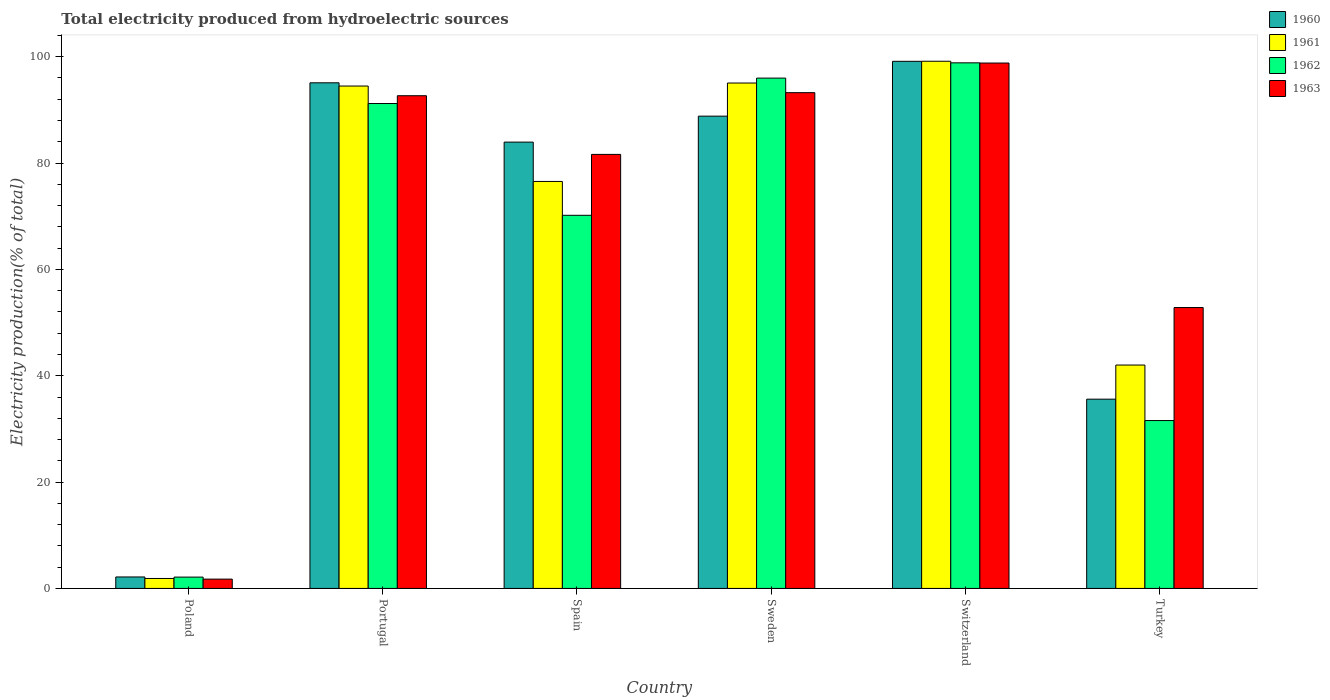How many different coloured bars are there?
Offer a very short reply. 4. How many bars are there on the 5th tick from the left?
Provide a succinct answer. 4. What is the total electricity produced in 1963 in Portugal?
Your answer should be compact. 92.66. Across all countries, what is the maximum total electricity produced in 1960?
Offer a very short reply. 99.13. Across all countries, what is the minimum total electricity produced in 1963?
Ensure brevity in your answer.  1.75. In which country was the total electricity produced in 1962 maximum?
Ensure brevity in your answer.  Switzerland. What is the total total electricity produced in 1960 in the graph?
Your answer should be very brief. 404.73. What is the difference between the total electricity produced in 1960 in Sweden and that in Turkey?
Provide a short and direct response. 53.22. What is the difference between the total electricity produced in 1963 in Sweden and the total electricity produced in 1960 in Switzerland?
Your answer should be very brief. -5.89. What is the average total electricity produced in 1961 per country?
Provide a short and direct response. 68.18. What is the difference between the total electricity produced of/in 1962 and total electricity produced of/in 1960 in Spain?
Give a very brief answer. -13.76. What is the ratio of the total electricity produced in 1963 in Portugal to that in Turkey?
Your answer should be compact. 1.75. Is the total electricity produced in 1963 in Spain less than that in Turkey?
Keep it short and to the point. No. What is the difference between the highest and the second highest total electricity produced in 1961?
Your answer should be very brief. 4.67. What is the difference between the highest and the lowest total electricity produced in 1961?
Offer a very short reply. 97.27. In how many countries, is the total electricity produced in 1963 greater than the average total electricity produced in 1963 taken over all countries?
Keep it short and to the point. 4. Is the sum of the total electricity produced in 1961 in Spain and Turkey greater than the maximum total electricity produced in 1962 across all countries?
Offer a very short reply. Yes. Is it the case that in every country, the sum of the total electricity produced in 1960 and total electricity produced in 1962 is greater than the sum of total electricity produced in 1963 and total electricity produced in 1961?
Make the answer very short. No. What does the 3rd bar from the right in Sweden represents?
Your answer should be compact. 1961. How many bars are there?
Your answer should be very brief. 24. How many countries are there in the graph?
Provide a succinct answer. 6. Are the values on the major ticks of Y-axis written in scientific E-notation?
Provide a succinct answer. No. Does the graph contain any zero values?
Give a very brief answer. No. Where does the legend appear in the graph?
Provide a short and direct response. Top right. How many legend labels are there?
Your answer should be compact. 4. How are the legend labels stacked?
Ensure brevity in your answer.  Vertical. What is the title of the graph?
Make the answer very short. Total electricity produced from hydroelectric sources. What is the label or title of the X-axis?
Your answer should be compact. Country. What is the Electricity production(% of total) in 1960 in Poland?
Give a very brief answer. 2.16. What is the Electricity production(% of total) of 1961 in Poland?
Your answer should be compact. 1.87. What is the Electricity production(% of total) of 1962 in Poland?
Your response must be concise. 2.13. What is the Electricity production(% of total) of 1963 in Poland?
Give a very brief answer. 1.75. What is the Electricity production(% of total) in 1960 in Portugal?
Offer a very short reply. 95.09. What is the Electricity production(% of total) of 1961 in Portugal?
Ensure brevity in your answer.  94.48. What is the Electricity production(% of total) of 1962 in Portugal?
Offer a very short reply. 91.19. What is the Electricity production(% of total) in 1963 in Portugal?
Provide a short and direct response. 92.66. What is the Electricity production(% of total) in 1960 in Spain?
Your answer should be compact. 83.94. What is the Electricity production(% of total) in 1961 in Spain?
Offer a very short reply. 76.54. What is the Electricity production(% of total) in 1962 in Spain?
Make the answer very short. 70.17. What is the Electricity production(% of total) of 1963 in Spain?
Your answer should be compact. 81.63. What is the Electricity production(% of total) of 1960 in Sweden?
Offer a very short reply. 88.82. What is the Electricity production(% of total) in 1961 in Sweden?
Your answer should be very brief. 95.05. What is the Electricity production(% of total) of 1962 in Sweden?
Keep it short and to the point. 95.98. What is the Electricity production(% of total) in 1963 in Sweden?
Give a very brief answer. 93.24. What is the Electricity production(% of total) in 1960 in Switzerland?
Your answer should be very brief. 99.13. What is the Electricity production(% of total) of 1961 in Switzerland?
Your answer should be compact. 99.15. What is the Electricity production(% of total) in 1962 in Switzerland?
Provide a succinct answer. 98.85. What is the Electricity production(% of total) in 1963 in Switzerland?
Provide a succinct answer. 98.81. What is the Electricity production(% of total) of 1960 in Turkey?
Provide a short and direct response. 35.6. What is the Electricity production(% of total) in 1961 in Turkey?
Your answer should be very brief. 42.01. What is the Electricity production(% of total) of 1962 in Turkey?
Give a very brief answer. 31.57. What is the Electricity production(% of total) of 1963 in Turkey?
Keep it short and to the point. 52.82. Across all countries, what is the maximum Electricity production(% of total) in 1960?
Provide a succinct answer. 99.13. Across all countries, what is the maximum Electricity production(% of total) of 1961?
Give a very brief answer. 99.15. Across all countries, what is the maximum Electricity production(% of total) in 1962?
Keep it short and to the point. 98.85. Across all countries, what is the maximum Electricity production(% of total) of 1963?
Offer a terse response. 98.81. Across all countries, what is the minimum Electricity production(% of total) of 1960?
Provide a succinct answer. 2.16. Across all countries, what is the minimum Electricity production(% of total) of 1961?
Provide a short and direct response. 1.87. Across all countries, what is the minimum Electricity production(% of total) in 1962?
Offer a very short reply. 2.13. Across all countries, what is the minimum Electricity production(% of total) of 1963?
Provide a succinct answer. 1.75. What is the total Electricity production(% of total) of 1960 in the graph?
Your answer should be compact. 404.73. What is the total Electricity production(% of total) of 1961 in the graph?
Offer a terse response. 409.1. What is the total Electricity production(% of total) of 1962 in the graph?
Give a very brief answer. 389.89. What is the total Electricity production(% of total) of 1963 in the graph?
Provide a short and direct response. 420.91. What is the difference between the Electricity production(% of total) in 1960 in Poland and that in Portugal?
Offer a terse response. -92.93. What is the difference between the Electricity production(% of total) in 1961 in Poland and that in Portugal?
Provide a succinct answer. -92.61. What is the difference between the Electricity production(% of total) in 1962 in Poland and that in Portugal?
Give a very brief answer. -89.06. What is the difference between the Electricity production(% of total) of 1963 in Poland and that in Portugal?
Your answer should be very brief. -90.91. What is the difference between the Electricity production(% of total) in 1960 in Poland and that in Spain?
Offer a very short reply. -81.78. What is the difference between the Electricity production(% of total) in 1961 in Poland and that in Spain?
Provide a short and direct response. -74.67. What is the difference between the Electricity production(% of total) in 1962 in Poland and that in Spain?
Your answer should be compact. -68.04. What is the difference between the Electricity production(% of total) of 1963 in Poland and that in Spain?
Provide a succinct answer. -79.88. What is the difference between the Electricity production(% of total) of 1960 in Poland and that in Sweden?
Keep it short and to the point. -86.66. What is the difference between the Electricity production(% of total) in 1961 in Poland and that in Sweden?
Offer a terse response. -93.17. What is the difference between the Electricity production(% of total) in 1962 in Poland and that in Sweden?
Keep it short and to the point. -93.84. What is the difference between the Electricity production(% of total) in 1963 in Poland and that in Sweden?
Ensure brevity in your answer.  -91.48. What is the difference between the Electricity production(% of total) in 1960 in Poland and that in Switzerland?
Your response must be concise. -96.97. What is the difference between the Electricity production(% of total) in 1961 in Poland and that in Switzerland?
Give a very brief answer. -97.27. What is the difference between the Electricity production(% of total) in 1962 in Poland and that in Switzerland?
Your response must be concise. -96.71. What is the difference between the Electricity production(% of total) of 1963 in Poland and that in Switzerland?
Your answer should be compact. -97.06. What is the difference between the Electricity production(% of total) of 1960 in Poland and that in Turkey?
Provide a succinct answer. -33.44. What is the difference between the Electricity production(% of total) in 1961 in Poland and that in Turkey?
Keep it short and to the point. -40.14. What is the difference between the Electricity production(% of total) in 1962 in Poland and that in Turkey?
Make the answer very short. -29.44. What is the difference between the Electricity production(% of total) of 1963 in Poland and that in Turkey?
Keep it short and to the point. -51.07. What is the difference between the Electricity production(% of total) in 1960 in Portugal and that in Spain?
Provide a short and direct response. 11.15. What is the difference between the Electricity production(% of total) of 1961 in Portugal and that in Spain?
Your answer should be compact. 17.94. What is the difference between the Electricity production(% of total) in 1962 in Portugal and that in Spain?
Provide a short and direct response. 21.02. What is the difference between the Electricity production(% of total) in 1963 in Portugal and that in Spain?
Your answer should be very brief. 11.03. What is the difference between the Electricity production(% of total) of 1960 in Portugal and that in Sweden?
Your response must be concise. 6.27. What is the difference between the Electricity production(% of total) in 1961 in Portugal and that in Sweden?
Give a very brief answer. -0.57. What is the difference between the Electricity production(% of total) of 1962 in Portugal and that in Sweden?
Provide a short and direct response. -4.78. What is the difference between the Electricity production(% of total) of 1963 in Portugal and that in Sweden?
Your response must be concise. -0.58. What is the difference between the Electricity production(% of total) in 1960 in Portugal and that in Switzerland?
Offer a very short reply. -4.04. What is the difference between the Electricity production(% of total) in 1961 in Portugal and that in Switzerland?
Provide a short and direct response. -4.67. What is the difference between the Electricity production(% of total) of 1962 in Portugal and that in Switzerland?
Your answer should be very brief. -7.65. What is the difference between the Electricity production(% of total) in 1963 in Portugal and that in Switzerland?
Provide a short and direct response. -6.15. What is the difference between the Electricity production(% of total) of 1960 in Portugal and that in Turkey?
Ensure brevity in your answer.  59.49. What is the difference between the Electricity production(% of total) of 1961 in Portugal and that in Turkey?
Your response must be concise. 52.47. What is the difference between the Electricity production(% of total) of 1962 in Portugal and that in Turkey?
Your answer should be very brief. 59.62. What is the difference between the Electricity production(% of total) in 1963 in Portugal and that in Turkey?
Offer a very short reply. 39.84. What is the difference between the Electricity production(% of total) of 1960 in Spain and that in Sweden?
Your answer should be compact. -4.88. What is the difference between the Electricity production(% of total) in 1961 in Spain and that in Sweden?
Give a very brief answer. -18.51. What is the difference between the Electricity production(% of total) in 1962 in Spain and that in Sweden?
Your answer should be compact. -25.8. What is the difference between the Electricity production(% of total) of 1963 in Spain and that in Sweden?
Your response must be concise. -11.61. What is the difference between the Electricity production(% of total) in 1960 in Spain and that in Switzerland?
Offer a very short reply. -15.19. What is the difference between the Electricity production(% of total) in 1961 in Spain and that in Switzerland?
Your answer should be very brief. -22.61. What is the difference between the Electricity production(% of total) in 1962 in Spain and that in Switzerland?
Your response must be concise. -28.67. What is the difference between the Electricity production(% of total) in 1963 in Spain and that in Switzerland?
Offer a very short reply. -17.18. What is the difference between the Electricity production(% of total) of 1960 in Spain and that in Turkey?
Provide a succinct answer. 48.34. What is the difference between the Electricity production(% of total) of 1961 in Spain and that in Turkey?
Offer a terse response. 34.53. What is the difference between the Electricity production(% of total) in 1962 in Spain and that in Turkey?
Make the answer very short. 38.6. What is the difference between the Electricity production(% of total) in 1963 in Spain and that in Turkey?
Your response must be concise. 28.8. What is the difference between the Electricity production(% of total) in 1960 in Sweden and that in Switzerland?
Your response must be concise. -10.31. What is the difference between the Electricity production(% of total) of 1961 in Sweden and that in Switzerland?
Your answer should be very brief. -4.1. What is the difference between the Electricity production(% of total) of 1962 in Sweden and that in Switzerland?
Offer a very short reply. -2.87. What is the difference between the Electricity production(% of total) of 1963 in Sweden and that in Switzerland?
Give a very brief answer. -5.57. What is the difference between the Electricity production(% of total) of 1960 in Sweden and that in Turkey?
Your answer should be compact. 53.22. What is the difference between the Electricity production(% of total) in 1961 in Sweden and that in Turkey?
Offer a terse response. 53.04. What is the difference between the Electricity production(% of total) of 1962 in Sweden and that in Turkey?
Keep it short and to the point. 64.4. What is the difference between the Electricity production(% of total) of 1963 in Sweden and that in Turkey?
Provide a succinct answer. 40.41. What is the difference between the Electricity production(% of total) in 1960 in Switzerland and that in Turkey?
Provide a short and direct response. 63.54. What is the difference between the Electricity production(% of total) of 1961 in Switzerland and that in Turkey?
Ensure brevity in your answer.  57.13. What is the difference between the Electricity production(% of total) of 1962 in Switzerland and that in Turkey?
Your answer should be very brief. 67.27. What is the difference between the Electricity production(% of total) of 1963 in Switzerland and that in Turkey?
Offer a very short reply. 45.98. What is the difference between the Electricity production(% of total) of 1960 in Poland and the Electricity production(% of total) of 1961 in Portugal?
Your response must be concise. -92.32. What is the difference between the Electricity production(% of total) in 1960 in Poland and the Electricity production(% of total) in 1962 in Portugal?
Your answer should be compact. -89.03. What is the difference between the Electricity production(% of total) in 1960 in Poland and the Electricity production(% of total) in 1963 in Portugal?
Your response must be concise. -90.5. What is the difference between the Electricity production(% of total) of 1961 in Poland and the Electricity production(% of total) of 1962 in Portugal?
Give a very brief answer. -89.32. What is the difference between the Electricity production(% of total) of 1961 in Poland and the Electricity production(% of total) of 1963 in Portugal?
Offer a terse response. -90.79. What is the difference between the Electricity production(% of total) of 1962 in Poland and the Electricity production(% of total) of 1963 in Portugal?
Provide a short and direct response. -90.53. What is the difference between the Electricity production(% of total) in 1960 in Poland and the Electricity production(% of total) in 1961 in Spain?
Your response must be concise. -74.38. What is the difference between the Electricity production(% of total) in 1960 in Poland and the Electricity production(% of total) in 1962 in Spain?
Your response must be concise. -68.01. What is the difference between the Electricity production(% of total) in 1960 in Poland and the Electricity production(% of total) in 1963 in Spain?
Your response must be concise. -79.47. What is the difference between the Electricity production(% of total) in 1961 in Poland and the Electricity production(% of total) in 1962 in Spain?
Make the answer very short. -68.3. What is the difference between the Electricity production(% of total) of 1961 in Poland and the Electricity production(% of total) of 1963 in Spain?
Ensure brevity in your answer.  -79.75. What is the difference between the Electricity production(% of total) of 1962 in Poland and the Electricity production(% of total) of 1963 in Spain?
Offer a very short reply. -79.5. What is the difference between the Electricity production(% of total) in 1960 in Poland and the Electricity production(% of total) in 1961 in Sweden?
Ensure brevity in your answer.  -92.89. What is the difference between the Electricity production(% of total) of 1960 in Poland and the Electricity production(% of total) of 1962 in Sweden?
Make the answer very short. -93.82. What is the difference between the Electricity production(% of total) in 1960 in Poland and the Electricity production(% of total) in 1963 in Sweden?
Your answer should be compact. -91.08. What is the difference between the Electricity production(% of total) in 1961 in Poland and the Electricity production(% of total) in 1962 in Sweden?
Offer a terse response. -94.1. What is the difference between the Electricity production(% of total) of 1961 in Poland and the Electricity production(% of total) of 1963 in Sweden?
Your answer should be compact. -91.36. What is the difference between the Electricity production(% of total) of 1962 in Poland and the Electricity production(% of total) of 1963 in Sweden?
Provide a succinct answer. -91.1. What is the difference between the Electricity production(% of total) in 1960 in Poland and the Electricity production(% of total) in 1961 in Switzerland?
Keep it short and to the point. -96.99. What is the difference between the Electricity production(% of total) of 1960 in Poland and the Electricity production(% of total) of 1962 in Switzerland?
Make the answer very short. -96.69. What is the difference between the Electricity production(% of total) in 1960 in Poland and the Electricity production(% of total) in 1963 in Switzerland?
Your answer should be very brief. -96.65. What is the difference between the Electricity production(% of total) in 1961 in Poland and the Electricity production(% of total) in 1962 in Switzerland?
Offer a terse response. -96.97. What is the difference between the Electricity production(% of total) in 1961 in Poland and the Electricity production(% of total) in 1963 in Switzerland?
Your response must be concise. -96.93. What is the difference between the Electricity production(% of total) of 1962 in Poland and the Electricity production(% of total) of 1963 in Switzerland?
Your response must be concise. -96.67. What is the difference between the Electricity production(% of total) in 1960 in Poland and the Electricity production(% of total) in 1961 in Turkey?
Your response must be concise. -39.85. What is the difference between the Electricity production(% of total) of 1960 in Poland and the Electricity production(% of total) of 1962 in Turkey?
Offer a very short reply. -29.41. What is the difference between the Electricity production(% of total) of 1960 in Poland and the Electricity production(% of total) of 1963 in Turkey?
Offer a very short reply. -50.67. What is the difference between the Electricity production(% of total) of 1961 in Poland and the Electricity production(% of total) of 1962 in Turkey?
Give a very brief answer. -29.7. What is the difference between the Electricity production(% of total) of 1961 in Poland and the Electricity production(% of total) of 1963 in Turkey?
Provide a succinct answer. -50.95. What is the difference between the Electricity production(% of total) of 1962 in Poland and the Electricity production(% of total) of 1963 in Turkey?
Your answer should be compact. -50.69. What is the difference between the Electricity production(% of total) of 1960 in Portugal and the Electricity production(% of total) of 1961 in Spain?
Offer a very short reply. 18.55. What is the difference between the Electricity production(% of total) of 1960 in Portugal and the Electricity production(% of total) of 1962 in Spain?
Your answer should be very brief. 24.92. What is the difference between the Electricity production(% of total) in 1960 in Portugal and the Electricity production(% of total) in 1963 in Spain?
Your answer should be very brief. 13.46. What is the difference between the Electricity production(% of total) in 1961 in Portugal and the Electricity production(% of total) in 1962 in Spain?
Provide a short and direct response. 24.31. What is the difference between the Electricity production(% of total) of 1961 in Portugal and the Electricity production(% of total) of 1963 in Spain?
Offer a very short reply. 12.85. What is the difference between the Electricity production(% of total) of 1962 in Portugal and the Electricity production(% of total) of 1963 in Spain?
Provide a short and direct response. 9.57. What is the difference between the Electricity production(% of total) in 1960 in Portugal and the Electricity production(% of total) in 1961 in Sweden?
Offer a terse response. 0.04. What is the difference between the Electricity production(% of total) of 1960 in Portugal and the Electricity production(% of total) of 1962 in Sweden?
Give a very brief answer. -0.89. What is the difference between the Electricity production(% of total) of 1960 in Portugal and the Electricity production(% of total) of 1963 in Sweden?
Your answer should be compact. 1.85. What is the difference between the Electricity production(% of total) of 1961 in Portugal and the Electricity production(% of total) of 1962 in Sweden?
Your answer should be very brief. -1.49. What is the difference between the Electricity production(% of total) of 1961 in Portugal and the Electricity production(% of total) of 1963 in Sweden?
Offer a terse response. 1.24. What is the difference between the Electricity production(% of total) of 1962 in Portugal and the Electricity production(% of total) of 1963 in Sweden?
Make the answer very short. -2.04. What is the difference between the Electricity production(% of total) in 1960 in Portugal and the Electricity production(% of total) in 1961 in Switzerland?
Provide a succinct answer. -4.06. What is the difference between the Electricity production(% of total) of 1960 in Portugal and the Electricity production(% of total) of 1962 in Switzerland?
Make the answer very short. -3.76. What is the difference between the Electricity production(% of total) in 1960 in Portugal and the Electricity production(% of total) in 1963 in Switzerland?
Give a very brief answer. -3.72. What is the difference between the Electricity production(% of total) of 1961 in Portugal and the Electricity production(% of total) of 1962 in Switzerland?
Your answer should be compact. -4.37. What is the difference between the Electricity production(% of total) in 1961 in Portugal and the Electricity production(% of total) in 1963 in Switzerland?
Keep it short and to the point. -4.33. What is the difference between the Electricity production(% of total) in 1962 in Portugal and the Electricity production(% of total) in 1963 in Switzerland?
Provide a short and direct response. -7.61. What is the difference between the Electricity production(% of total) of 1960 in Portugal and the Electricity production(% of total) of 1961 in Turkey?
Offer a very short reply. 53.08. What is the difference between the Electricity production(% of total) of 1960 in Portugal and the Electricity production(% of total) of 1962 in Turkey?
Ensure brevity in your answer.  63.52. What is the difference between the Electricity production(% of total) of 1960 in Portugal and the Electricity production(% of total) of 1963 in Turkey?
Your answer should be very brief. 42.27. What is the difference between the Electricity production(% of total) of 1961 in Portugal and the Electricity production(% of total) of 1962 in Turkey?
Offer a very short reply. 62.91. What is the difference between the Electricity production(% of total) of 1961 in Portugal and the Electricity production(% of total) of 1963 in Turkey?
Keep it short and to the point. 41.66. What is the difference between the Electricity production(% of total) of 1962 in Portugal and the Electricity production(% of total) of 1963 in Turkey?
Keep it short and to the point. 38.37. What is the difference between the Electricity production(% of total) of 1960 in Spain and the Electricity production(% of total) of 1961 in Sweden?
Offer a terse response. -11.11. What is the difference between the Electricity production(% of total) of 1960 in Spain and the Electricity production(% of total) of 1962 in Sweden?
Offer a very short reply. -12.04. What is the difference between the Electricity production(% of total) in 1960 in Spain and the Electricity production(% of total) in 1963 in Sweden?
Ensure brevity in your answer.  -9.3. What is the difference between the Electricity production(% of total) of 1961 in Spain and the Electricity production(% of total) of 1962 in Sweden?
Give a very brief answer. -19.44. What is the difference between the Electricity production(% of total) of 1961 in Spain and the Electricity production(% of total) of 1963 in Sweden?
Offer a very short reply. -16.7. What is the difference between the Electricity production(% of total) of 1962 in Spain and the Electricity production(% of total) of 1963 in Sweden?
Offer a very short reply. -23.06. What is the difference between the Electricity production(% of total) of 1960 in Spain and the Electricity production(% of total) of 1961 in Switzerland?
Offer a very short reply. -15.21. What is the difference between the Electricity production(% of total) in 1960 in Spain and the Electricity production(% of total) in 1962 in Switzerland?
Give a very brief answer. -14.91. What is the difference between the Electricity production(% of total) of 1960 in Spain and the Electricity production(% of total) of 1963 in Switzerland?
Your answer should be very brief. -14.87. What is the difference between the Electricity production(% of total) in 1961 in Spain and the Electricity production(% of total) in 1962 in Switzerland?
Your answer should be very brief. -22.31. What is the difference between the Electricity production(% of total) in 1961 in Spain and the Electricity production(% of total) in 1963 in Switzerland?
Your answer should be very brief. -22.27. What is the difference between the Electricity production(% of total) of 1962 in Spain and the Electricity production(% of total) of 1963 in Switzerland?
Offer a terse response. -28.63. What is the difference between the Electricity production(% of total) of 1960 in Spain and the Electricity production(% of total) of 1961 in Turkey?
Offer a terse response. 41.92. What is the difference between the Electricity production(% of total) in 1960 in Spain and the Electricity production(% of total) in 1962 in Turkey?
Keep it short and to the point. 52.36. What is the difference between the Electricity production(% of total) in 1960 in Spain and the Electricity production(% of total) in 1963 in Turkey?
Give a very brief answer. 31.11. What is the difference between the Electricity production(% of total) in 1961 in Spain and the Electricity production(% of total) in 1962 in Turkey?
Keep it short and to the point. 44.97. What is the difference between the Electricity production(% of total) in 1961 in Spain and the Electricity production(% of total) in 1963 in Turkey?
Ensure brevity in your answer.  23.72. What is the difference between the Electricity production(% of total) of 1962 in Spain and the Electricity production(% of total) of 1963 in Turkey?
Keep it short and to the point. 17.35. What is the difference between the Electricity production(% of total) of 1960 in Sweden and the Electricity production(% of total) of 1961 in Switzerland?
Make the answer very short. -10.33. What is the difference between the Electricity production(% of total) of 1960 in Sweden and the Electricity production(% of total) of 1962 in Switzerland?
Offer a terse response. -10.03. What is the difference between the Electricity production(% of total) of 1960 in Sweden and the Electricity production(% of total) of 1963 in Switzerland?
Provide a short and direct response. -9.99. What is the difference between the Electricity production(% of total) in 1961 in Sweden and the Electricity production(% of total) in 1962 in Switzerland?
Provide a short and direct response. -3.8. What is the difference between the Electricity production(% of total) of 1961 in Sweden and the Electricity production(% of total) of 1963 in Switzerland?
Keep it short and to the point. -3.76. What is the difference between the Electricity production(% of total) in 1962 in Sweden and the Electricity production(% of total) in 1963 in Switzerland?
Provide a short and direct response. -2.83. What is the difference between the Electricity production(% of total) of 1960 in Sweden and the Electricity production(% of total) of 1961 in Turkey?
Make the answer very short. 46.81. What is the difference between the Electricity production(% of total) of 1960 in Sweden and the Electricity production(% of total) of 1962 in Turkey?
Provide a short and direct response. 57.25. What is the difference between the Electricity production(% of total) of 1960 in Sweden and the Electricity production(% of total) of 1963 in Turkey?
Offer a terse response. 36. What is the difference between the Electricity production(% of total) in 1961 in Sweden and the Electricity production(% of total) in 1962 in Turkey?
Your response must be concise. 63.48. What is the difference between the Electricity production(% of total) in 1961 in Sweden and the Electricity production(% of total) in 1963 in Turkey?
Ensure brevity in your answer.  42.22. What is the difference between the Electricity production(% of total) in 1962 in Sweden and the Electricity production(% of total) in 1963 in Turkey?
Your answer should be very brief. 43.15. What is the difference between the Electricity production(% of total) in 1960 in Switzerland and the Electricity production(% of total) in 1961 in Turkey?
Your response must be concise. 57.12. What is the difference between the Electricity production(% of total) in 1960 in Switzerland and the Electricity production(% of total) in 1962 in Turkey?
Provide a succinct answer. 67.56. What is the difference between the Electricity production(% of total) of 1960 in Switzerland and the Electricity production(% of total) of 1963 in Turkey?
Keep it short and to the point. 46.31. What is the difference between the Electricity production(% of total) of 1961 in Switzerland and the Electricity production(% of total) of 1962 in Turkey?
Your answer should be compact. 67.57. What is the difference between the Electricity production(% of total) in 1961 in Switzerland and the Electricity production(% of total) in 1963 in Turkey?
Keep it short and to the point. 46.32. What is the difference between the Electricity production(% of total) of 1962 in Switzerland and the Electricity production(% of total) of 1963 in Turkey?
Your answer should be compact. 46.02. What is the average Electricity production(% of total) of 1960 per country?
Offer a terse response. 67.45. What is the average Electricity production(% of total) in 1961 per country?
Keep it short and to the point. 68.18. What is the average Electricity production(% of total) of 1962 per country?
Your answer should be compact. 64.98. What is the average Electricity production(% of total) of 1963 per country?
Give a very brief answer. 70.15. What is the difference between the Electricity production(% of total) in 1960 and Electricity production(% of total) in 1961 in Poland?
Make the answer very short. 0.28. What is the difference between the Electricity production(% of total) of 1960 and Electricity production(% of total) of 1962 in Poland?
Offer a terse response. 0.03. What is the difference between the Electricity production(% of total) of 1960 and Electricity production(% of total) of 1963 in Poland?
Ensure brevity in your answer.  0.41. What is the difference between the Electricity production(% of total) of 1961 and Electricity production(% of total) of 1962 in Poland?
Your answer should be compact. -0.26. What is the difference between the Electricity production(% of total) of 1961 and Electricity production(% of total) of 1963 in Poland?
Your response must be concise. 0.12. What is the difference between the Electricity production(% of total) in 1962 and Electricity production(% of total) in 1963 in Poland?
Your response must be concise. 0.38. What is the difference between the Electricity production(% of total) of 1960 and Electricity production(% of total) of 1961 in Portugal?
Provide a short and direct response. 0.61. What is the difference between the Electricity production(% of total) of 1960 and Electricity production(% of total) of 1962 in Portugal?
Your answer should be compact. 3.9. What is the difference between the Electricity production(% of total) in 1960 and Electricity production(% of total) in 1963 in Portugal?
Offer a very short reply. 2.43. What is the difference between the Electricity production(% of total) of 1961 and Electricity production(% of total) of 1962 in Portugal?
Provide a succinct answer. 3.29. What is the difference between the Electricity production(% of total) in 1961 and Electricity production(% of total) in 1963 in Portugal?
Keep it short and to the point. 1.82. What is the difference between the Electricity production(% of total) in 1962 and Electricity production(% of total) in 1963 in Portugal?
Provide a succinct answer. -1.47. What is the difference between the Electricity production(% of total) of 1960 and Electricity production(% of total) of 1961 in Spain?
Offer a very short reply. 7.4. What is the difference between the Electricity production(% of total) in 1960 and Electricity production(% of total) in 1962 in Spain?
Make the answer very short. 13.76. What is the difference between the Electricity production(% of total) of 1960 and Electricity production(% of total) of 1963 in Spain?
Your response must be concise. 2.31. What is the difference between the Electricity production(% of total) of 1961 and Electricity production(% of total) of 1962 in Spain?
Offer a terse response. 6.37. What is the difference between the Electricity production(% of total) of 1961 and Electricity production(% of total) of 1963 in Spain?
Your answer should be compact. -5.09. What is the difference between the Electricity production(% of total) in 1962 and Electricity production(% of total) in 1963 in Spain?
Your answer should be very brief. -11.45. What is the difference between the Electricity production(% of total) in 1960 and Electricity production(% of total) in 1961 in Sweden?
Provide a succinct answer. -6.23. What is the difference between the Electricity production(% of total) in 1960 and Electricity production(% of total) in 1962 in Sweden?
Give a very brief answer. -7.16. What is the difference between the Electricity production(% of total) in 1960 and Electricity production(% of total) in 1963 in Sweden?
Offer a very short reply. -4.42. What is the difference between the Electricity production(% of total) in 1961 and Electricity production(% of total) in 1962 in Sweden?
Offer a very short reply. -0.93. What is the difference between the Electricity production(% of total) in 1961 and Electricity production(% of total) in 1963 in Sweden?
Provide a succinct answer. 1.81. What is the difference between the Electricity production(% of total) in 1962 and Electricity production(% of total) in 1963 in Sweden?
Your answer should be very brief. 2.74. What is the difference between the Electricity production(% of total) in 1960 and Electricity production(% of total) in 1961 in Switzerland?
Offer a terse response. -0.02. What is the difference between the Electricity production(% of total) in 1960 and Electricity production(% of total) in 1962 in Switzerland?
Your answer should be very brief. 0.28. What is the difference between the Electricity production(% of total) in 1960 and Electricity production(% of total) in 1963 in Switzerland?
Offer a very short reply. 0.32. What is the difference between the Electricity production(% of total) of 1961 and Electricity production(% of total) of 1962 in Switzerland?
Your answer should be compact. 0.3. What is the difference between the Electricity production(% of total) of 1961 and Electricity production(% of total) of 1963 in Switzerland?
Your answer should be very brief. 0.34. What is the difference between the Electricity production(% of total) in 1962 and Electricity production(% of total) in 1963 in Switzerland?
Give a very brief answer. 0.04. What is the difference between the Electricity production(% of total) in 1960 and Electricity production(% of total) in 1961 in Turkey?
Provide a short and direct response. -6.42. What is the difference between the Electricity production(% of total) in 1960 and Electricity production(% of total) in 1962 in Turkey?
Provide a short and direct response. 4.02. What is the difference between the Electricity production(% of total) in 1960 and Electricity production(% of total) in 1963 in Turkey?
Ensure brevity in your answer.  -17.23. What is the difference between the Electricity production(% of total) of 1961 and Electricity production(% of total) of 1962 in Turkey?
Give a very brief answer. 10.44. What is the difference between the Electricity production(% of total) in 1961 and Electricity production(% of total) in 1963 in Turkey?
Offer a terse response. -10.81. What is the difference between the Electricity production(% of total) of 1962 and Electricity production(% of total) of 1963 in Turkey?
Provide a short and direct response. -21.25. What is the ratio of the Electricity production(% of total) in 1960 in Poland to that in Portugal?
Give a very brief answer. 0.02. What is the ratio of the Electricity production(% of total) of 1961 in Poland to that in Portugal?
Your answer should be very brief. 0.02. What is the ratio of the Electricity production(% of total) in 1962 in Poland to that in Portugal?
Make the answer very short. 0.02. What is the ratio of the Electricity production(% of total) in 1963 in Poland to that in Portugal?
Keep it short and to the point. 0.02. What is the ratio of the Electricity production(% of total) in 1960 in Poland to that in Spain?
Your response must be concise. 0.03. What is the ratio of the Electricity production(% of total) in 1961 in Poland to that in Spain?
Your response must be concise. 0.02. What is the ratio of the Electricity production(% of total) in 1962 in Poland to that in Spain?
Give a very brief answer. 0.03. What is the ratio of the Electricity production(% of total) in 1963 in Poland to that in Spain?
Provide a succinct answer. 0.02. What is the ratio of the Electricity production(% of total) of 1960 in Poland to that in Sweden?
Your response must be concise. 0.02. What is the ratio of the Electricity production(% of total) in 1961 in Poland to that in Sweden?
Ensure brevity in your answer.  0.02. What is the ratio of the Electricity production(% of total) in 1962 in Poland to that in Sweden?
Make the answer very short. 0.02. What is the ratio of the Electricity production(% of total) in 1963 in Poland to that in Sweden?
Keep it short and to the point. 0.02. What is the ratio of the Electricity production(% of total) of 1960 in Poland to that in Switzerland?
Give a very brief answer. 0.02. What is the ratio of the Electricity production(% of total) in 1961 in Poland to that in Switzerland?
Offer a very short reply. 0.02. What is the ratio of the Electricity production(% of total) in 1962 in Poland to that in Switzerland?
Keep it short and to the point. 0.02. What is the ratio of the Electricity production(% of total) of 1963 in Poland to that in Switzerland?
Offer a terse response. 0.02. What is the ratio of the Electricity production(% of total) of 1960 in Poland to that in Turkey?
Provide a succinct answer. 0.06. What is the ratio of the Electricity production(% of total) of 1961 in Poland to that in Turkey?
Provide a short and direct response. 0.04. What is the ratio of the Electricity production(% of total) in 1962 in Poland to that in Turkey?
Make the answer very short. 0.07. What is the ratio of the Electricity production(% of total) of 1963 in Poland to that in Turkey?
Provide a succinct answer. 0.03. What is the ratio of the Electricity production(% of total) of 1960 in Portugal to that in Spain?
Your response must be concise. 1.13. What is the ratio of the Electricity production(% of total) in 1961 in Portugal to that in Spain?
Provide a succinct answer. 1.23. What is the ratio of the Electricity production(% of total) of 1962 in Portugal to that in Spain?
Keep it short and to the point. 1.3. What is the ratio of the Electricity production(% of total) of 1963 in Portugal to that in Spain?
Your answer should be compact. 1.14. What is the ratio of the Electricity production(% of total) of 1960 in Portugal to that in Sweden?
Provide a short and direct response. 1.07. What is the ratio of the Electricity production(% of total) in 1961 in Portugal to that in Sweden?
Your response must be concise. 0.99. What is the ratio of the Electricity production(% of total) in 1962 in Portugal to that in Sweden?
Offer a very short reply. 0.95. What is the ratio of the Electricity production(% of total) of 1960 in Portugal to that in Switzerland?
Your answer should be compact. 0.96. What is the ratio of the Electricity production(% of total) in 1961 in Portugal to that in Switzerland?
Provide a short and direct response. 0.95. What is the ratio of the Electricity production(% of total) of 1962 in Portugal to that in Switzerland?
Keep it short and to the point. 0.92. What is the ratio of the Electricity production(% of total) of 1963 in Portugal to that in Switzerland?
Provide a succinct answer. 0.94. What is the ratio of the Electricity production(% of total) in 1960 in Portugal to that in Turkey?
Your response must be concise. 2.67. What is the ratio of the Electricity production(% of total) in 1961 in Portugal to that in Turkey?
Your response must be concise. 2.25. What is the ratio of the Electricity production(% of total) in 1962 in Portugal to that in Turkey?
Provide a succinct answer. 2.89. What is the ratio of the Electricity production(% of total) of 1963 in Portugal to that in Turkey?
Provide a succinct answer. 1.75. What is the ratio of the Electricity production(% of total) in 1960 in Spain to that in Sweden?
Your answer should be compact. 0.94. What is the ratio of the Electricity production(% of total) of 1961 in Spain to that in Sweden?
Your answer should be very brief. 0.81. What is the ratio of the Electricity production(% of total) of 1962 in Spain to that in Sweden?
Your answer should be compact. 0.73. What is the ratio of the Electricity production(% of total) of 1963 in Spain to that in Sweden?
Your answer should be very brief. 0.88. What is the ratio of the Electricity production(% of total) in 1960 in Spain to that in Switzerland?
Your response must be concise. 0.85. What is the ratio of the Electricity production(% of total) of 1961 in Spain to that in Switzerland?
Make the answer very short. 0.77. What is the ratio of the Electricity production(% of total) in 1962 in Spain to that in Switzerland?
Ensure brevity in your answer.  0.71. What is the ratio of the Electricity production(% of total) of 1963 in Spain to that in Switzerland?
Your answer should be very brief. 0.83. What is the ratio of the Electricity production(% of total) of 1960 in Spain to that in Turkey?
Provide a succinct answer. 2.36. What is the ratio of the Electricity production(% of total) in 1961 in Spain to that in Turkey?
Provide a short and direct response. 1.82. What is the ratio of the Electricity production(% of total) of 1962 in Spain to that in Turkey?
Keep it short and to the point. 2.22. What is the ratio of the Electricity production(% of total) in 1963 in Spain to that in Turkey?
Make the answer very short. 1.55. What is the ratio of the Electricity production(% of total) in 1960 in Sweden to that in Switzerland?
Your answer should be very brief. 0.9. What is the ratio of the Electricity production(% of total) in 1961 in Sweden to that in Switzerland?
Provide a short and direct response. 0.96. What is the ratio of the Electricity production(% of total) in 1962 in Sweden to that in Switzerland?
Your answer should be compact. 0.97. What is the ratio of the Electricity production(% of total) in 1963 in Sweden to that in Switzerland?
Ensure brevity in your answer.  0.94. What is the ratio of the Electricity production(% of total) of 1960 in Sweden to that in Turkey?
Keep it short and to the point. 2.5. What is the ratio of the Electricity production(% of total) of 1961 in Sweden to that in Turkey?
Offer a terse response. 2.26. What is the ratio of the Electricity production(% of total) of 1962 in Sweden to that in Turkey?
Give a very brief answer. 3.04. What is the ratio of the Electricity production(% of total) in 1963 in Sweden to that in Turkey?
Provide a succinct answer. 1.76. What is the ratio of the Electricity production(% of total) of 1960 in Switzerland to that in Turkey?
Offer a very short reply. 2.79. What is the ratio of the Electricity production(% of total) in 1961 in Switzerland to that in Turkey?
Make the answer very short. 2.36. What is the ratio of the Electricity production(% of total) of 1962 in Switzerland to that in Turkey?
Provide a succinct answer. 3.13. What is the ratio of the Electricity production(% of total) in 1963 in Switzerland to that in Turkey?
Your response must be concise. 1.87. What is the difference between the highest and the second highest Electricity production(% of total) of 1960?
Offer a very short reply. 4.04. What is the difference between the highest and the second highest Electricity production(% of total) in 1961?
Give a very brief answer. 4.1. What is the difference between the highest and the second highest Electricity production(% of total) in 1962?
Your response must be concise. 2.87. What is the difference between the highest and the second highest Electricity production(% of total) of 1963?
Keep it short and to the point. 5.57. What is the difference between the highest and the lowest Electricity production(% of total) in 1960?
Ensure brevity in your answer.  96.97. What is the difference between the highest and the lowest Electricity production(% of total) of 1961?
Provide a short and direct response. 97.27. What is the difference between the highest and the lowest Electricity production(% of total) in 1962?
Provide a short and direct response. 96.71. What is the difference between the highest and the lowest Electricity production(% of total) of 1963?
Give a very brief answer. 97.06. 